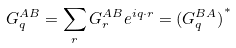<formula> <loc_0><loc_0><loc_500><loc_500>G _ { q } ^ { A B } = \sum _ { r } G _ { r } ^ { A B } e ^ { i { q } \cdot { r } } = { ( G _ { q } ^ { B A } ) } ^ { * }</formula> 